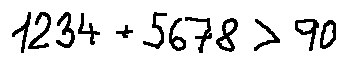<formula> <loc_0><loc_0><loc_500><loc_500>1 2 3 4 + 5 6 7 8 > 9 0</formula> 